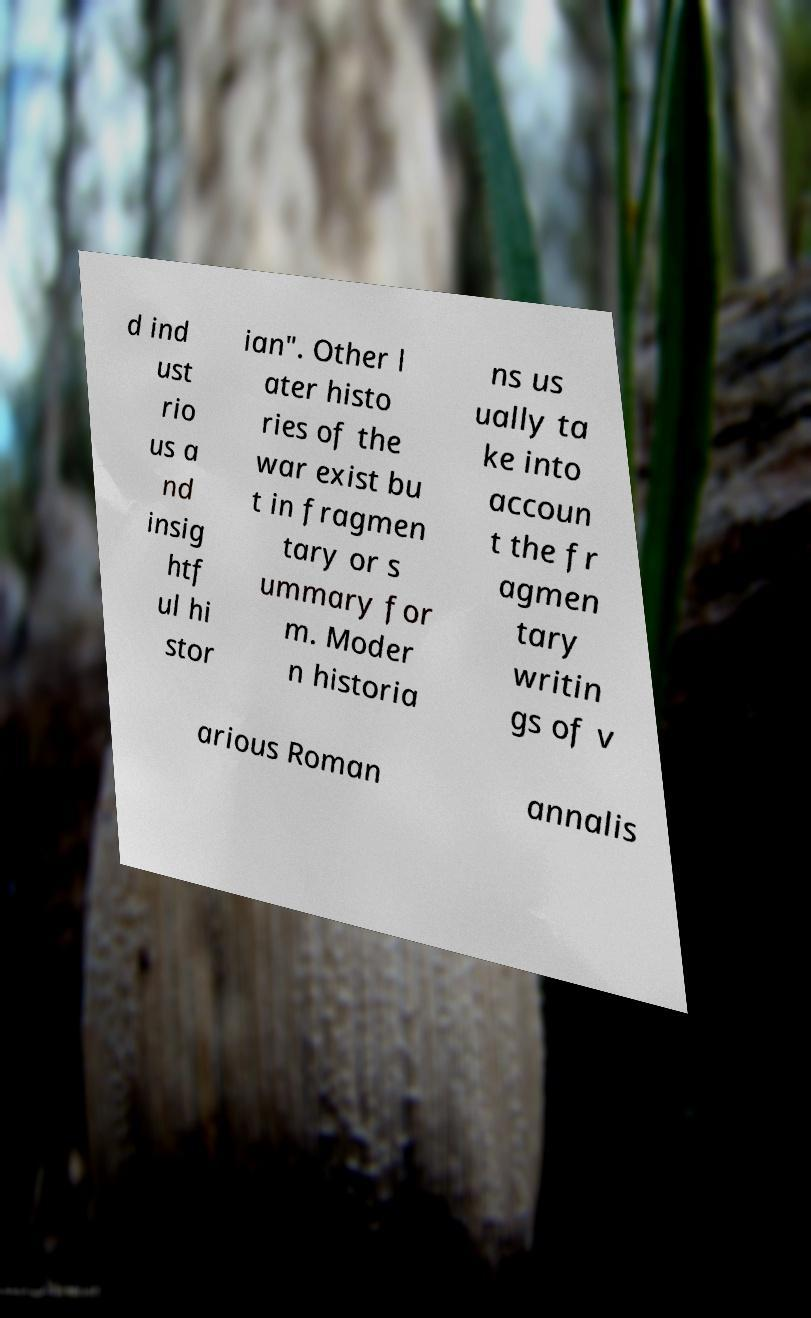Please read and relay the text visible in this image. What does it say? d ind ust rio us a nd insig htf ul hi stor ian". Other l ater histo ries of the war exist bu t in fragmen tary or s ummary for m. Moder n historia ns us ually ta ke into accoun t the fr agmen tary writin gs of v arious Roman annalis 